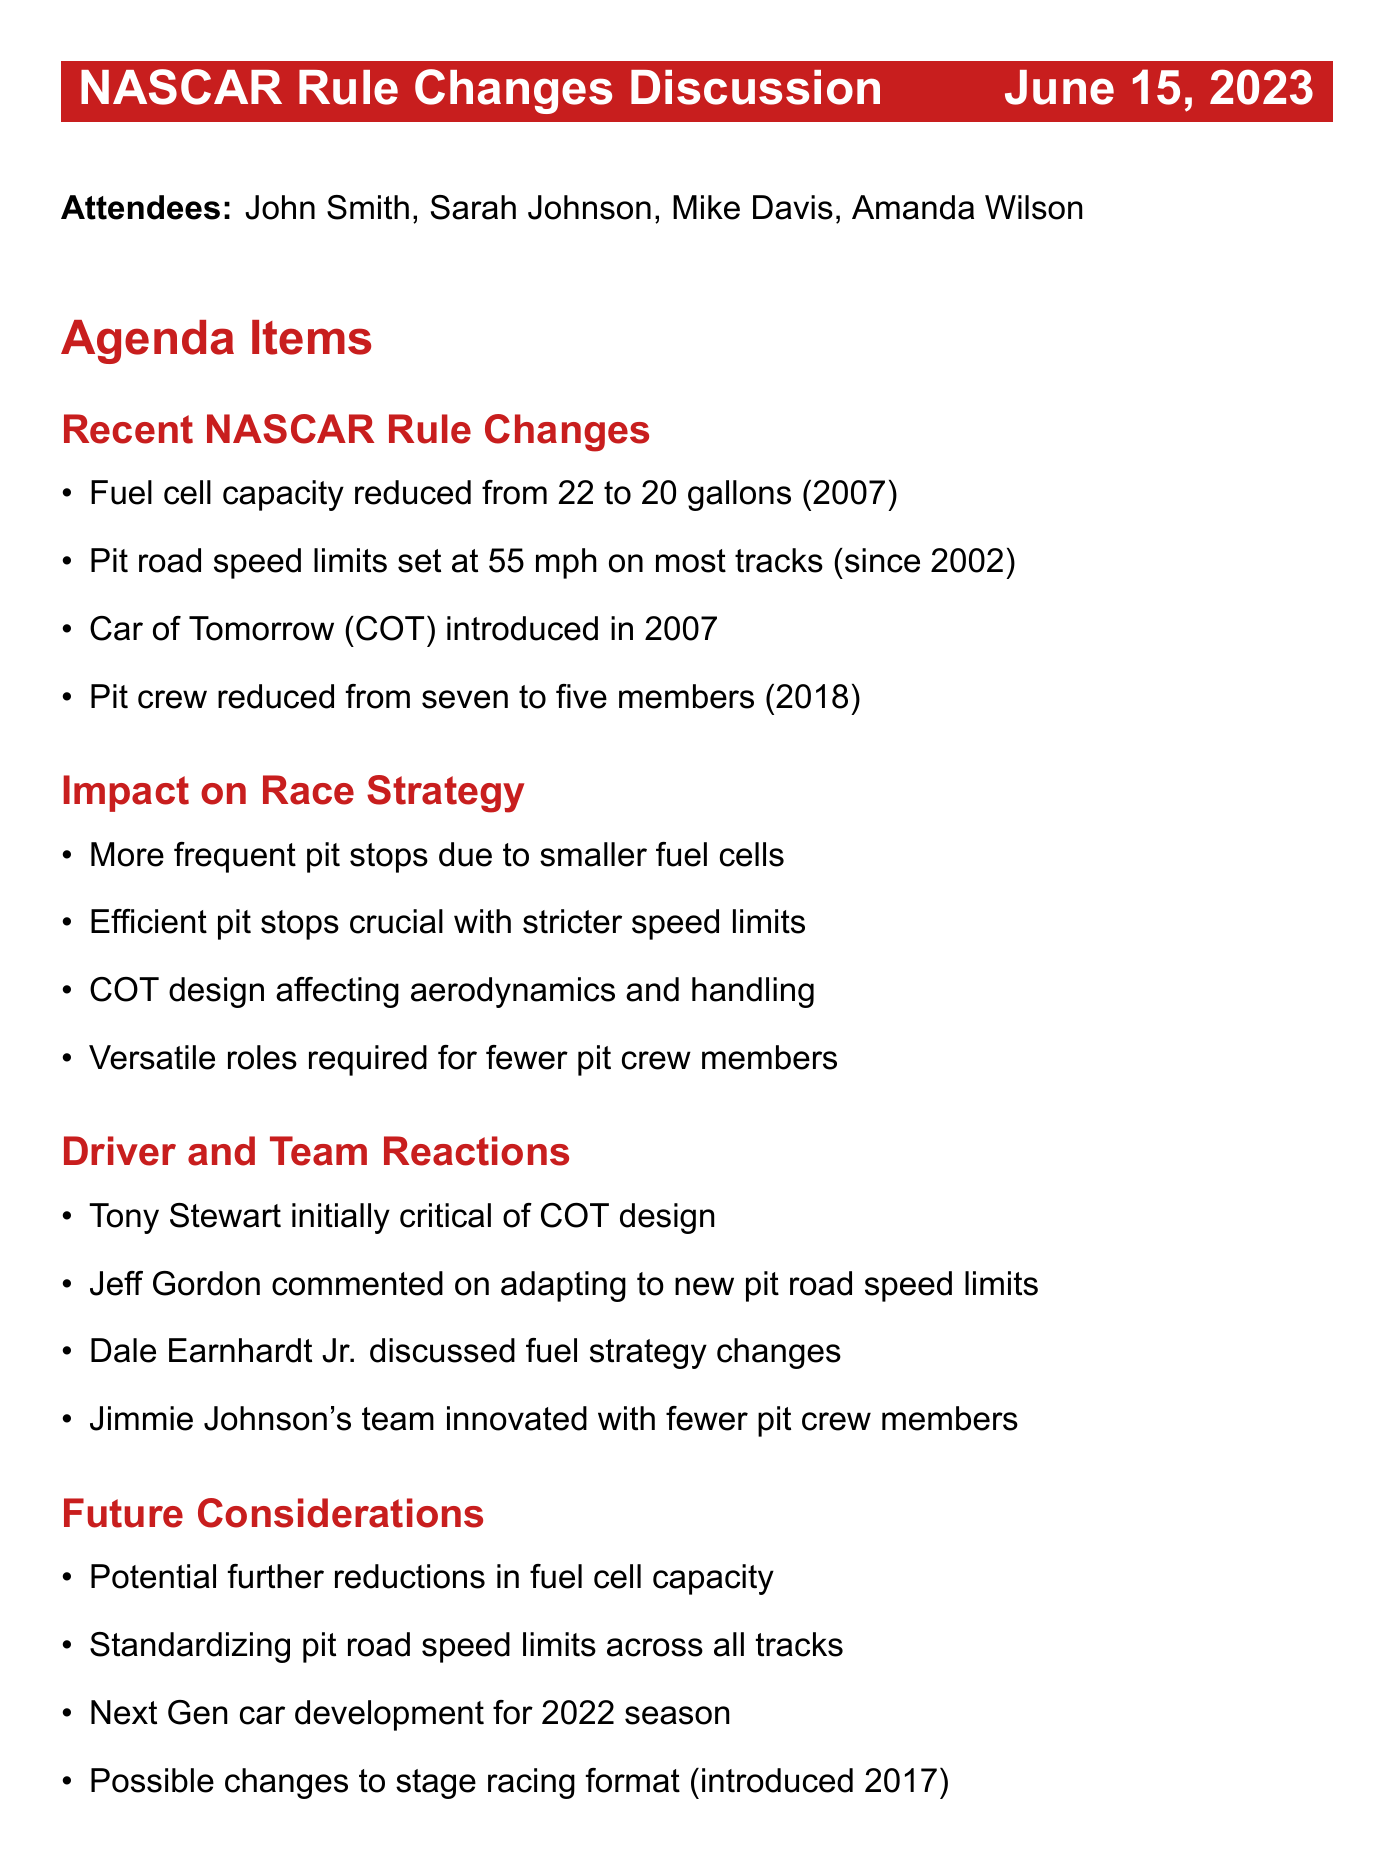What was the fuel cell capacity reduced to in 2007? The fuel cell capacity was reduced from 22 to 20 gallons in 2007.
Answer: 20 gallons What is the speed limit on pit road for most tracks? The pit road speed limit on most tracks is 55 mph.
Answer: 55 mph Which car was introduced in 2007? The "Car of Tomorrow" (COT) was introduced in 2007.
Answer: Car of Tomorrow (COT) How many members were in a pit crew prior to the 2018 changes? The pit crew was reduced from seven to five members in 2018, meaning they originally had seven.
Answer: seven Who initially criticized the COT design? Tony Stewart's initial criticism was directed towards the COT design.
Answer: Tony Stewart What is one potential future consideration mentioned regarding fuel cells? A potential future consideration is further reductions in fuel cell capacity.
Answer: Further reductions in fuel cell capacity What is the focus of the action item regarding driver feedback? The action item focuses on following up on driver feedback regarding recent rule changes.
Answer: Follow up on driver feedback What year was the introduction of the stage racing format? The stage racing format was introduced in 2017.
Answer: 2017 